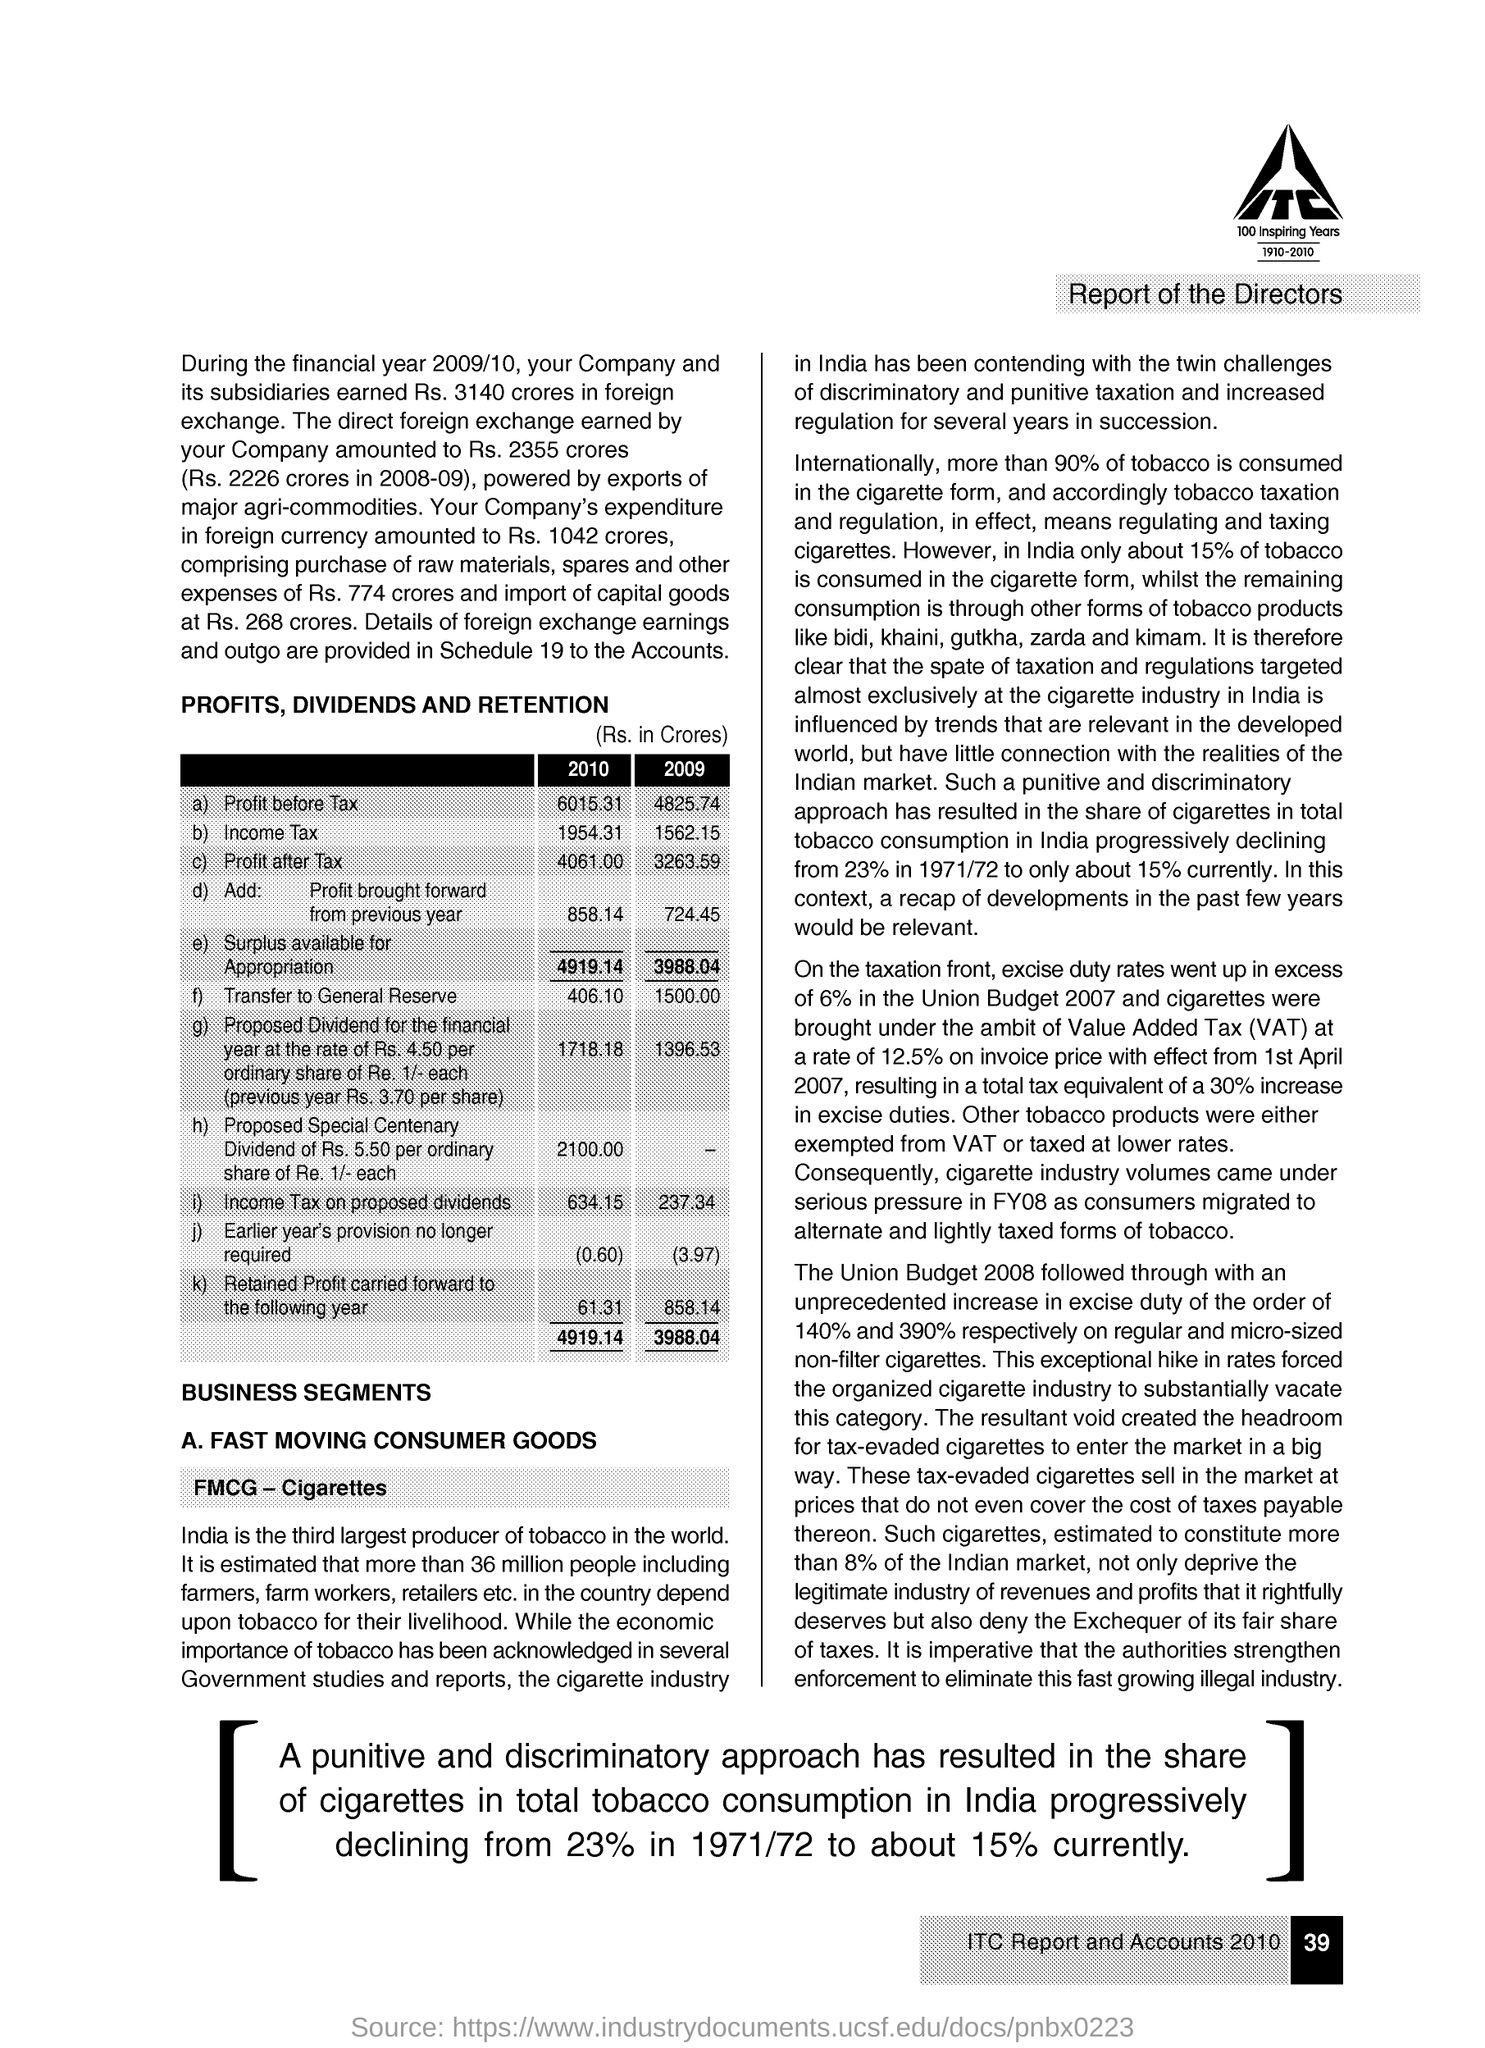What is written within the company logo in bold letters?
Provide a short and direct response. ITC. What is the main heading given?
Ensure brevity in your answer.  Report of the Directors. Provide the title of the table given in capital letters?
Provide a short and direct response. PROFITS, DIVIDENDS AND RETENTION. What is "Surplus available for Appropriation" for the year 2010?
Your answer should be compact. 4919.14. What is "Surplus available for Appropriation" for the year 2009?
Offer a terse response. 3988.04. Which "100 Inspiring Years" is mentioned under the logo?
Make the answer very short. 1910-2010. What is the "share of cigarettes in total tobacco consumption in India " during 1971/72?
Provide a short and direct response. 23%. Internationally more than what percentage of tobacco is consumed in the cigarette form?
Provide a short and direct response. 90%. In India about what percentage of tobacco is consumed in the cigarette form?
Provide a succinct answer. 15%. 